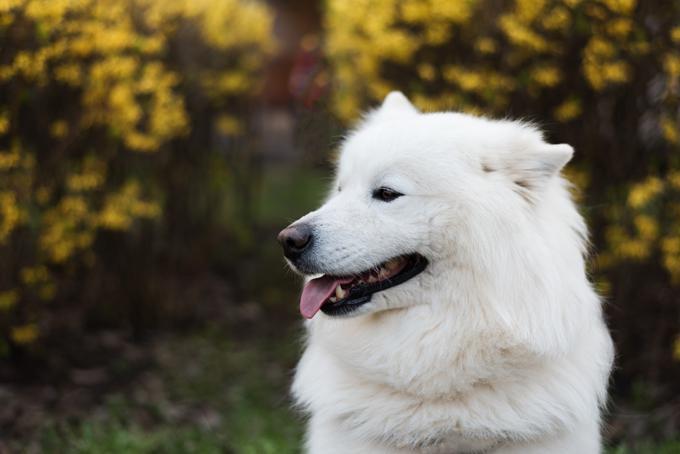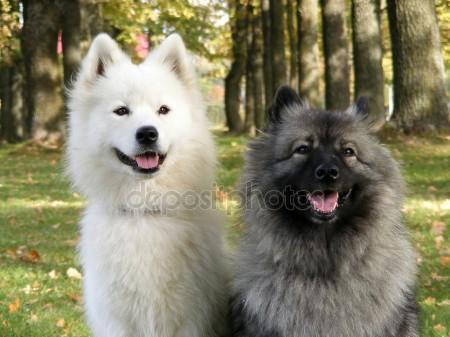The first image is the image on the left, the second image is the image on the right. For the images shown, is this caption "There are more dogs in the right image than in the left." true? Answer yes or no. Yes. 